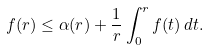<formula> <loc_0><loc_0><loc_500><loc_500>f ( r ) \leq \alpha ( r ) + \frac { 1 } { r } \int _ { 0 } ^ { r } f ( t ) \, d t .</formula> 